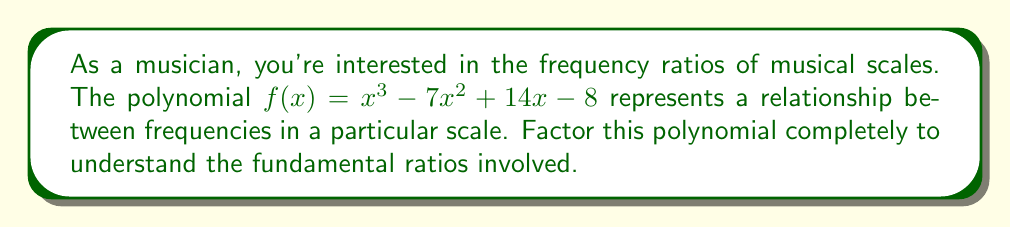Teach me how to tackle this problem. Let's approach this step-by-step:

1) First, we can try to guess a rational root. The possible rational roots are the factors of the constant term: ±1, ±2, ±4, ±8.

2) Testing these, we find that $f(1) = 0$. So $(x-1)$ is a factor.

3) We can use polynomial long division to divide $f(x)$ by $(x-1)$:

   $$x^3 - 7x^2 + 14x - 8 = (x-1)(x^2 - 6x + 8)$$

4) Now we need to factor the quadratic $x^2 - 6x + 8$

5) We can use the quadratic formula or recognize this as a difference of squares:
   
   $x^2 - 6x + 8 = (x-4)(x-2)$

6) Therefore, the complete factorization is:

   $$f(x) = (x-1)(x-4)(x-2)$$

This factorization reveals the fundamental frequency ratios in this scale: 1:1, 4:1, and 2:1. In musical terms, these represent the unison, two octaves, and one octave respectively.
Answer: $f(x) = (x-1)(x-4)(x-2)$ 